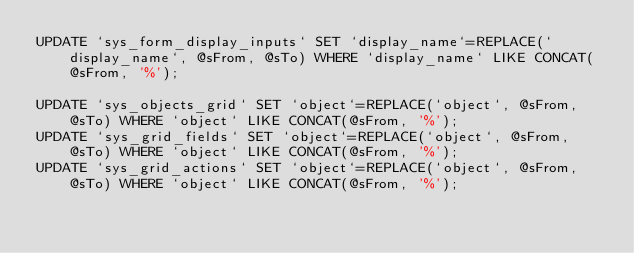Convert code to text. <code><loc_0><loc_0><loc_500><loc_500><_SQL_>UPDATE `sys_form_display_inputs` SET `display_name`=REPLACE(`display_name`, @sFrom, @sTo) WHERE `display_name` LIKE CONCAT(@sFrom, '%');

UPDATE `sys_objects_grid` SET `object`=REPLACE(`object`, @sFrom, @sTo) WHERE `object` LIKE CONCAT(@sFrom, '%');
UPDATE `sys_grid_fields` SET `object`=REPLACE(`object`, @sFrom, @sTo) WHERE `object` LIKE CONCAT(@sFrom, '%');
UPDATE `sys_grid_actions` SET `object`=REPLACE(`object`, @sFrom, @sTo) WHERE `object` LIKE CONCAT(@sFrom, '%');</code> 